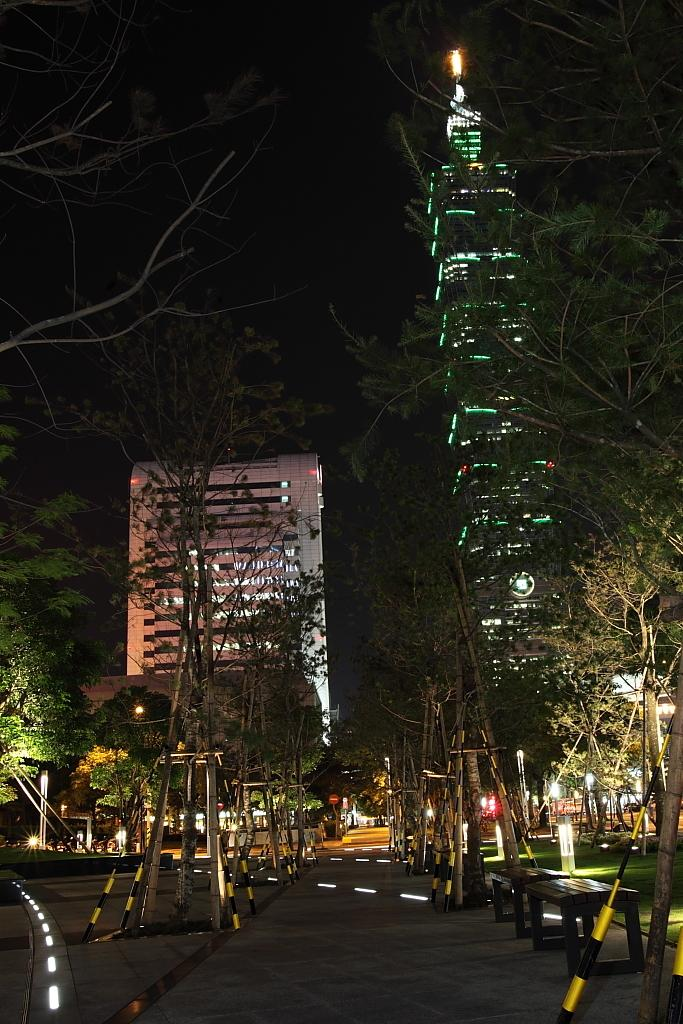What can be seen in the middle of the image? There are trees, buildings, lights, and a road in the middle of the image. What is located at the bottom of the image? There are benches, trees, and a road at the bottom of the image. What type of toothpaste is being used by the pets in the image? There are no pets or toothpaste present in the image. What can be seen in the can at the bottom of the image? There is no can present in the image. 